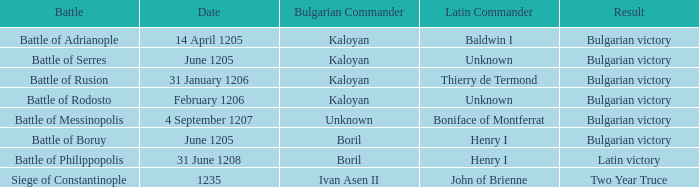What is the Bulgarian Commander of the Battle of Rusion? Kaloyan. Can you give me this table as a dict? {'header': ['Battle', 'Date', 'Bulgarian Commander', 'Latin Commander', 'Result'], 'rows': [['Battle of Adrianople', '14 April 1205', 'Kaloyan', 'Baldwin I', 'Bulgarian victory'], ['Battle of Serres', 'June 1205', 'Kaloyan', 'Unknown', 'Bulgarian victory'], ['Battle of Rusion', '31 January 1206', 'Kaloyan', 'Thierry de Termond', 'Bulgarian victory'], ['Battle of Rodosto', 'February 1206', 'Kaloyan', 'Unknown', 'Bulgarian victory'], ['Battle of Messinopolis', '4 September 1207', 'Unknown', 'Boniface of Montferrat', 'Bulgarian victory'], ['Battle of Boruy', 'June 1205', 'Boril', 'Henry I', 'Bulgarian victory'], ['Battle of Philippopolis', '31 June 1208', 'Boril', 'Henry I', 'Latin victory'], ['Siege of Constantinople', '1235', 'Ivan Asen II', 'John of Brienne', 'Two Year Truce']]} 